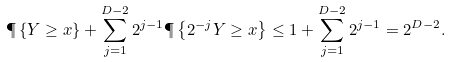Convert formula to latex. <formula><loc_0><loc_0><loc_500><loc_500>\P \left \{ Y \geq x \right \} + \sum _ { j = 1 } ^ { D - 2 } 2 ^ { j - 1 } \P \left \{ 2 ^ { - j } Y \geq x \right \} & \leq 1 + \sum _ { j = 1 } ^ { D - 2 } 2 ^ { j - 1 } = 2 ^ { D - 2 } .</formula> 